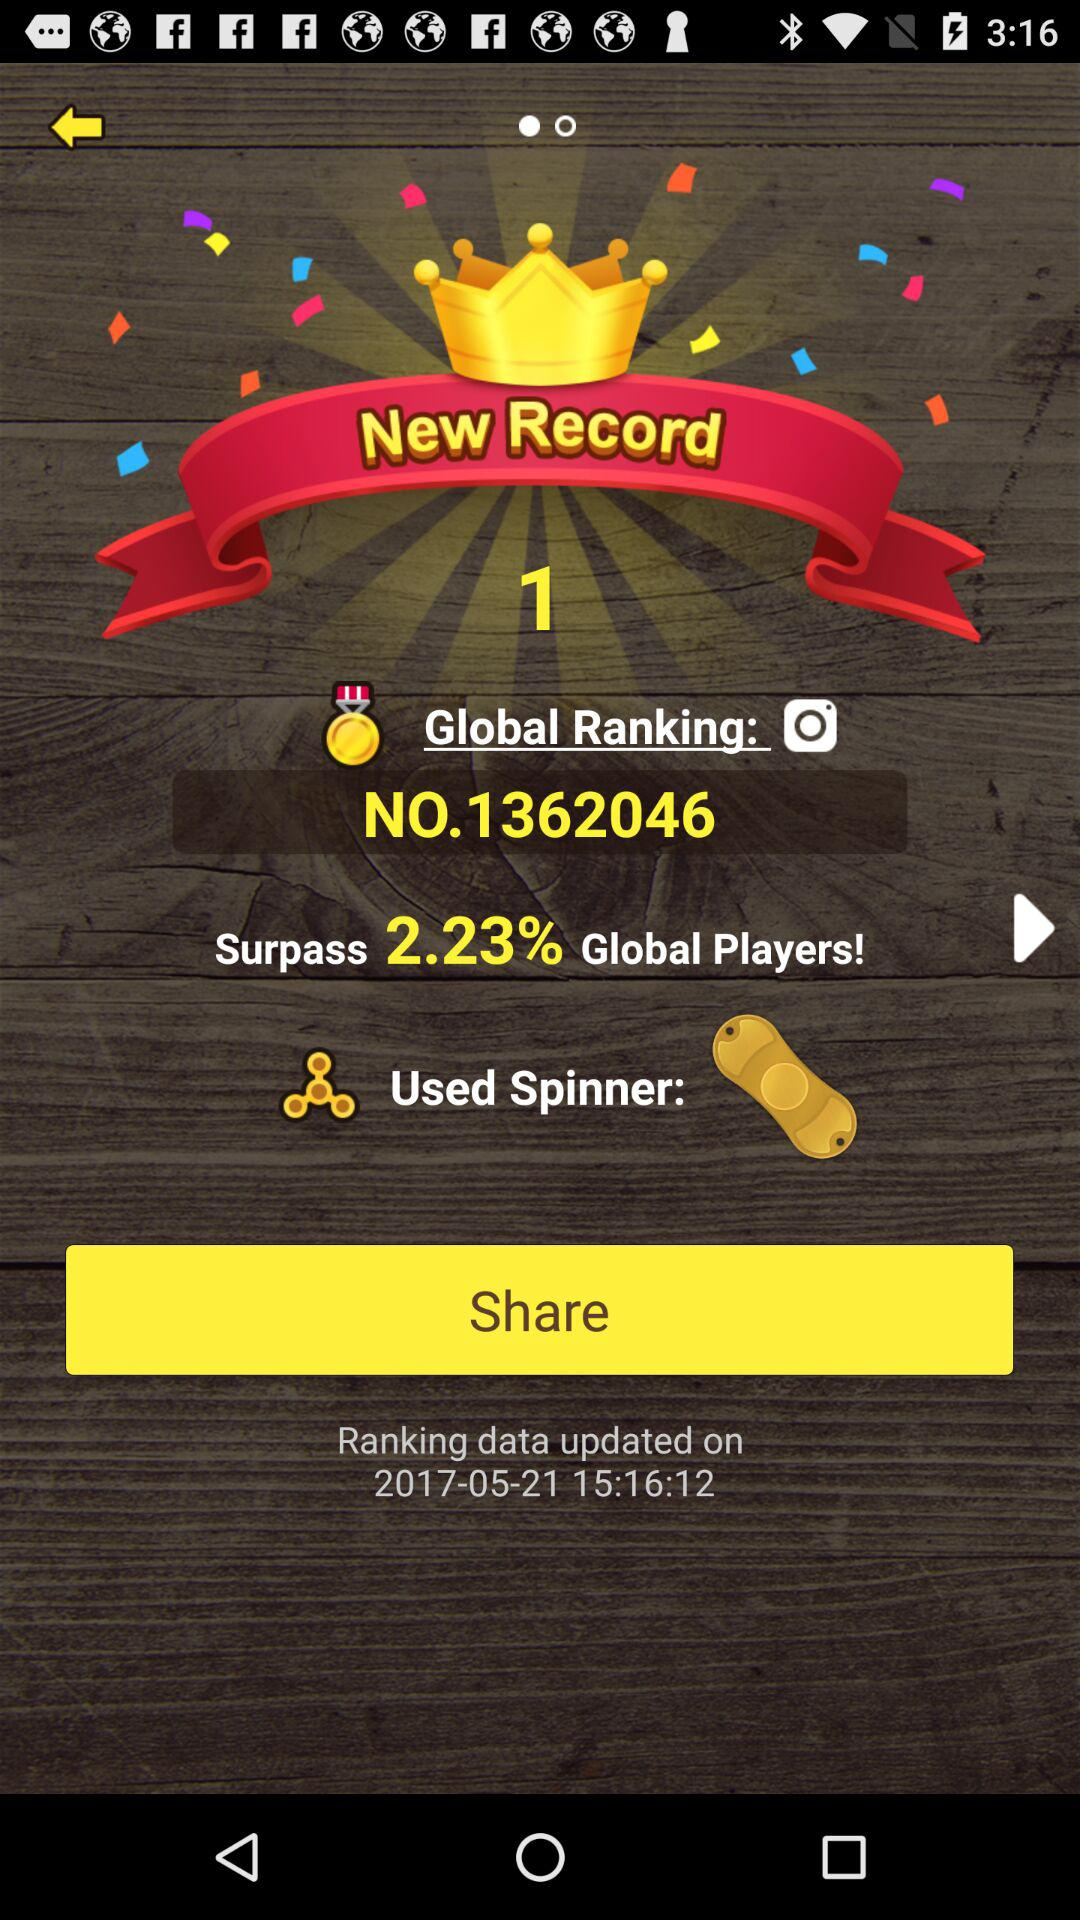What is the percentage of players that the current user has surpassed?
Answer the question using a single word or phrase. 2.23% 